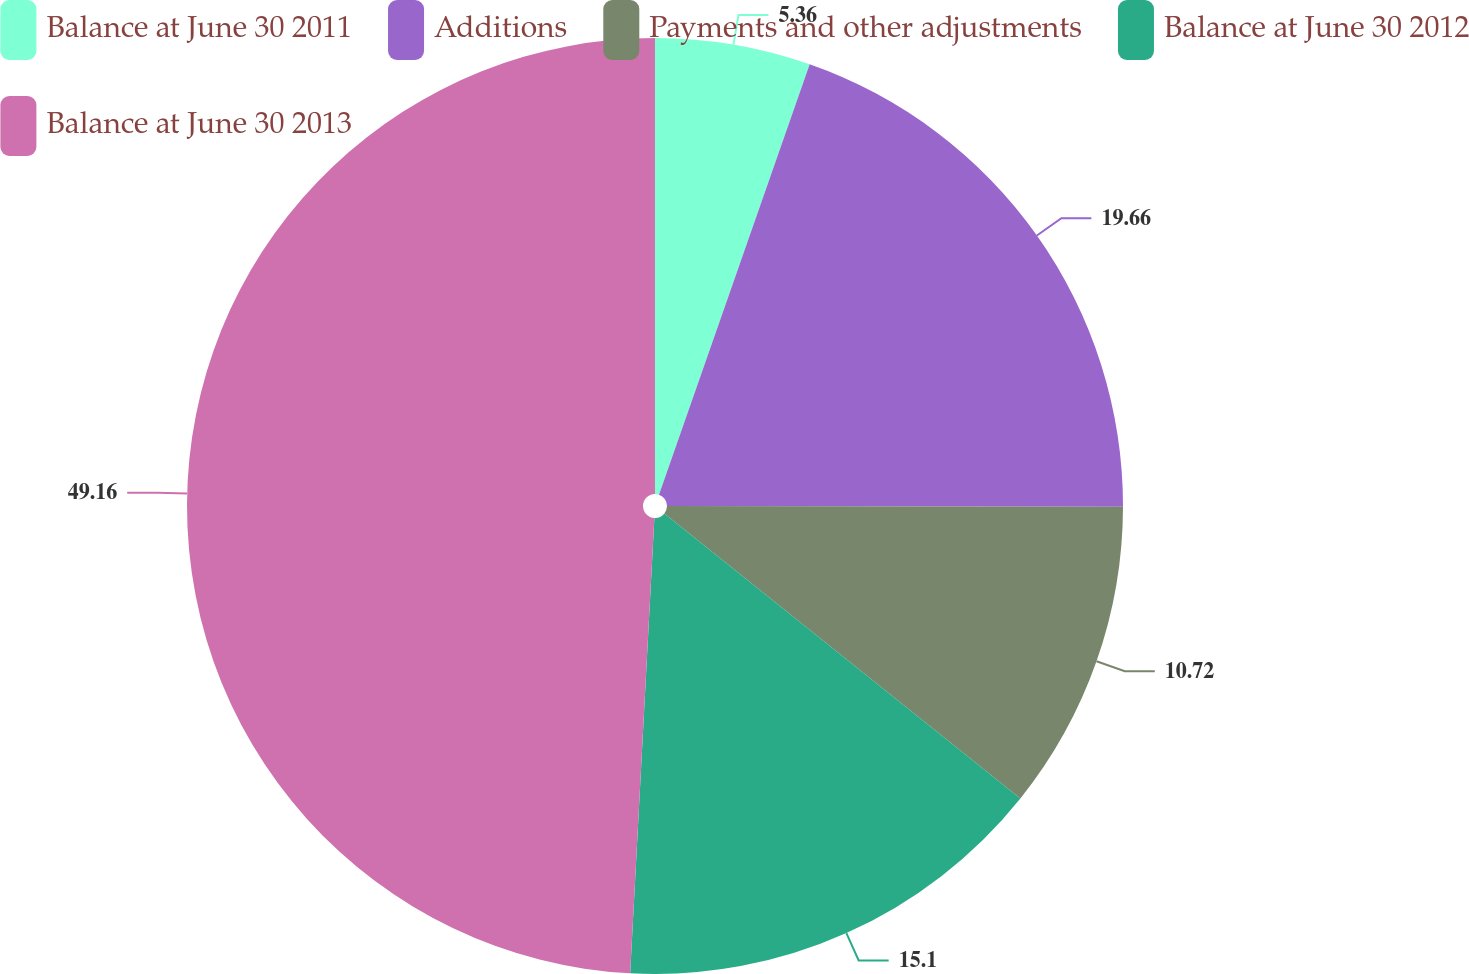Convert chart to OTSL. <chart><loc_0><loc_0><loc_500><loc_500><pie_chart><fcel>Balance at June 30 2011<fcel>Additions<fcel>Payments and other adjustments<fcel>Balance at June 30 2012<fcel>Balance at June 30 2013<nl><fcel>5.36%<fcel>19.66%<fcel>10.72%<fcel>15.1%<fcel>49.15%<nl></chart> 